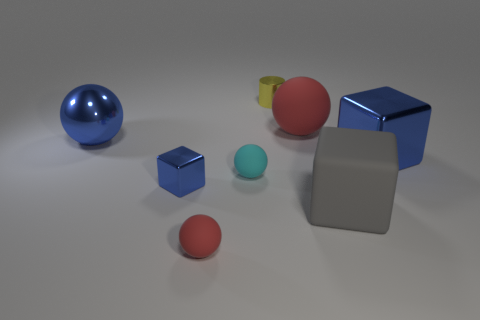Subtract 1 spheres. How many spheres are left? 3 Add 1 green metallic cubes. How many objects exist? 9 Subtract all cubes. How many objects are left? 5 Add 2 tiny yellow rubber balls. How many tiny yellow rubber balls exist? 2 Subtract 1 red balls. How many objects are left? 7 Subtract all tiny yellow cylinders. Subtract all big blue metallic balls. How many objects are left? 6 Add 6 small matte objects. How many small matte objects are left? 8 